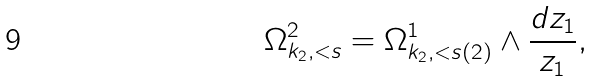<formula> <loc_0><loc_0><loc_500><loc_500>\Omega ^ { 2 } _ { k _ { 2 } , < s } = \Omega ^ { 1 } _ { k _ { 2 } , < s ( 2 ) } \wedge \frac { d z _ { 1 } } { z _ { 1 } } ,</formula> 